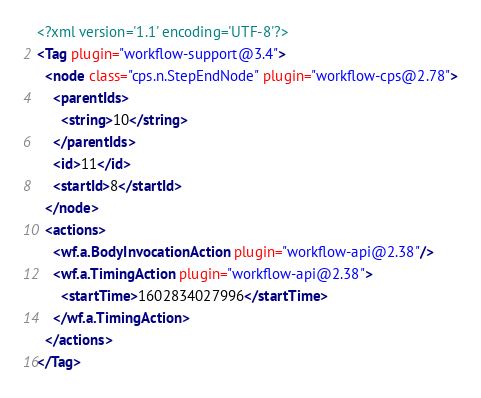<code> <loc_0><loc_0><loc_500><loc_500><_XML_><?xml version='1.1' encoding='UTF-8'?>
<Tag plugin="workflow-support@3.4">
  <node class="cps.n.StepEndNode" plugin="workflow-cps@2.78">
    <parentIds>
      <string>10</string>
    </parentIds>
    <id>11</id>
    <startId>8</startId>
  </node>
  <actions>
    <wf.a.BodyInvocationAction plugin="workflow-api@2.38"/>
    <wf.a.TimingAction plugin="workflow-api@2.38">
      <startTime>1602834027996</startTime>
    </wf.a.TimingAction>
  </actions>
</Tag></code> 